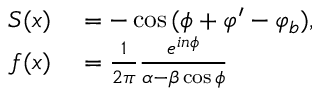Convert formula to latex. <formula><loc_0><loc_0><loc_500><loc_500>\begin{array} { r l } { S ( x ) } & = - \cos { ( \phi + \varphi ^ { \prime } - \varphi _ { b } ) } , } \\ { f ( x ) } & = \frac { 1 } { 2 \pi } \frac { e ^ { i n \phi } } { \alpha - \beta \cos { \phi } } } \end{array}</formula> 